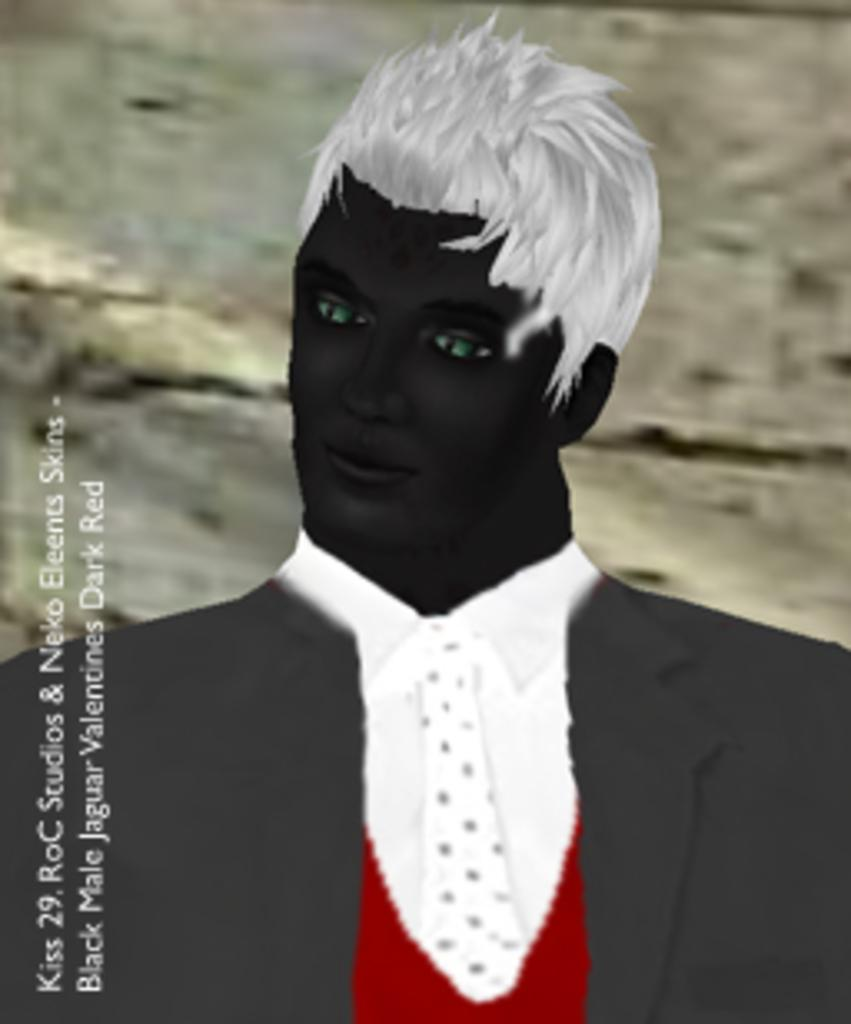What type of image is being described? The image is animated. Can you describe the person in the image? There is a person in the image, and they are wearing a suit. What is present on the left side of the image? There is text or matter written on the left side of the image. How many cars are visible in the image? There are no cars present in the image. Can you point out the map in the image? There is no map present in the image. 